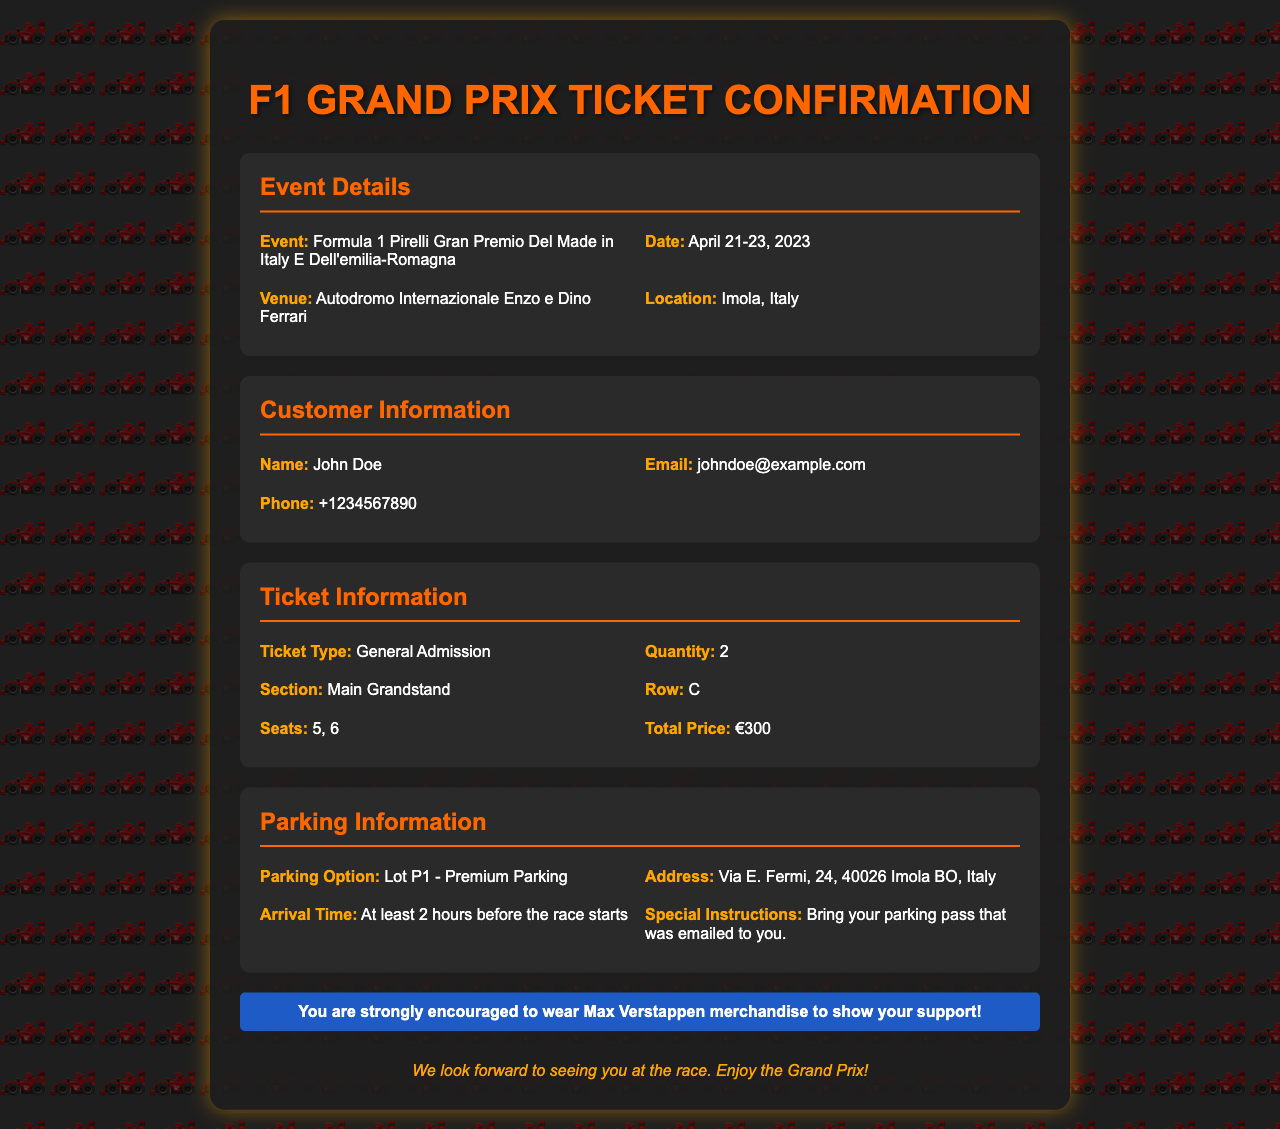what is the event name? The event name is mentioned in the Event Details section.
Answer: Formula 1 Pirelli Gran Premio Del Made in Italy E Dell'emilia-Romagna what is the date of the event? The date of the event is specified in the Event Details section.
Answer: April 21-23, 2023 who is the customer? The customer's name is given in the Customer Information section.
Answer: John Doe how many tickets were booked? The quantity of tickets purchased is mentioned in the Ticket Information section.
Answer: 2 what is the total price of the tickets? The total price is specified in the Ticket Information section.
Answer: €300 what is the parking option? The parking option is listed in the Parking Information section.
Answer: Lot P1 - Premium Parking what time should you arrive? The arrival time is detailed in the Parking Information section.
Answer: At least 2 hours before the race starts what special instructions are provided for parking? The special instructions are mentioned in the Parking Information section.
Answer: Bring your parking pass that was emailed to you which row are the seats in? The row information is given in the Ticket Information section.
Answer: C 